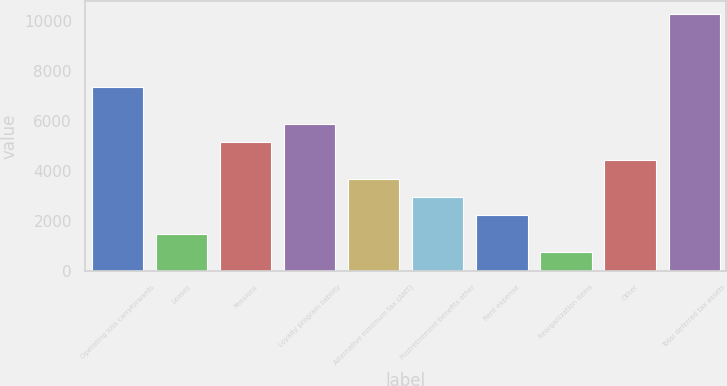Convert chart to OTSL. <chart><loc_0><loc_0><loc_500><loc_500><bar_chart><fcel>Operating loss carryforwards<fcel>Leases<fcel>Pensions<fcel>Loyalty program liability<fcel>Alternative minimum tax (AMT)<fcel>Postretirement benefits other<fcel>Rent expense<fcel>Reorganization items<fcel>Other<fcel>Total deferred tax assets<nl><fcel>7334<fcel>1486.8<fcel>5141.3<fcel>5872.2<fcel>3679.5<fcel>2948.6<fcel>2217.7<fcel>755.9<fcel>4410.4<fcel>10257.6<nl></chart> 